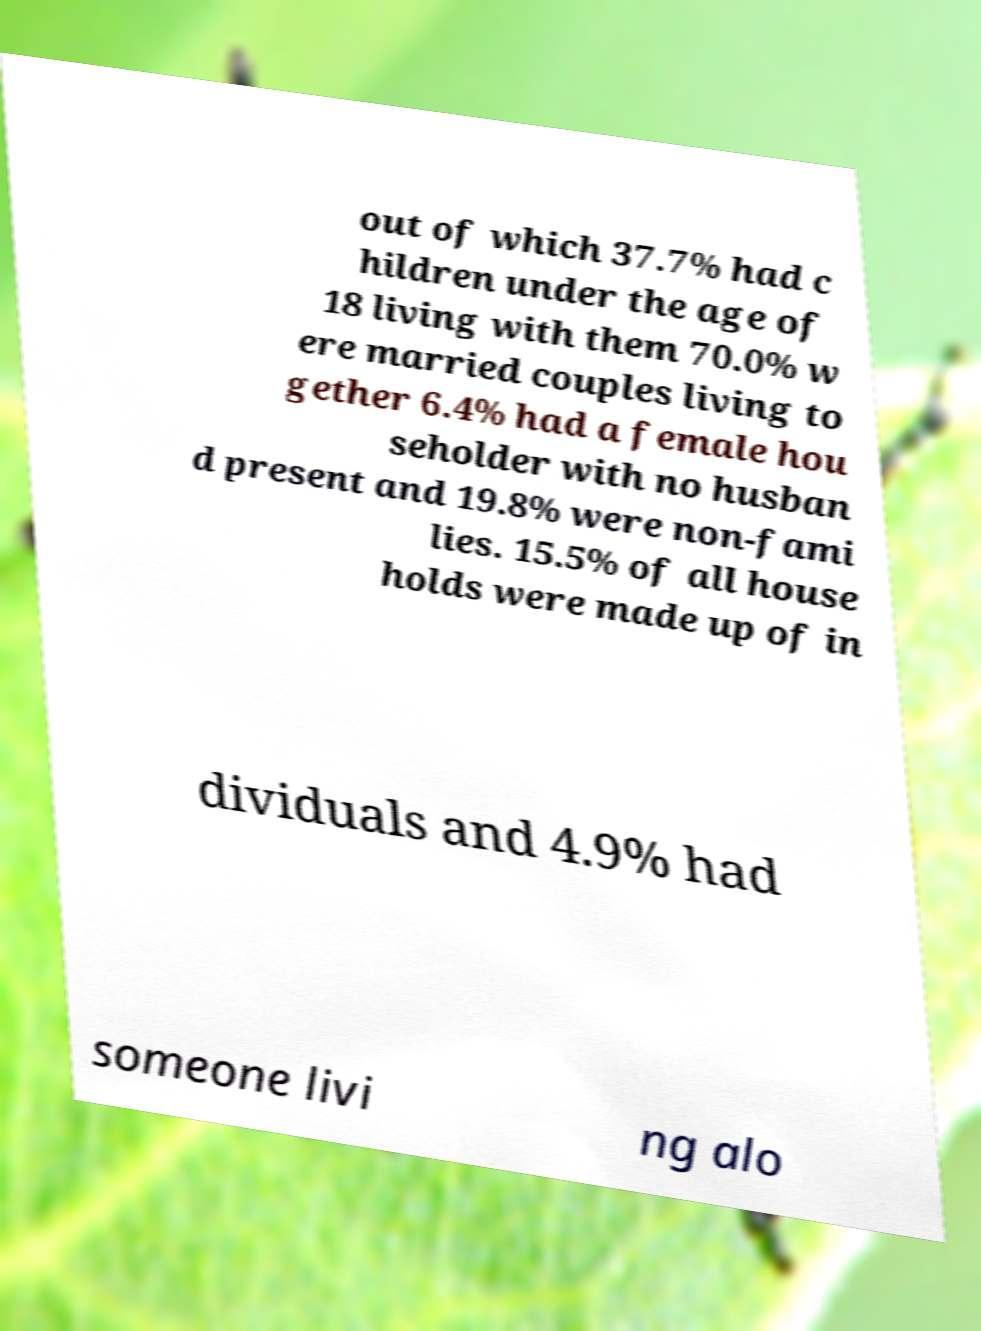Could you assist in decoding the text presented in this image and type it out clearly? out of which 37.7% had c hildren under the age of 18 living with them 70.0% w ere married couples living to gether 6.4% had a female hou seholder with no husban d present and 19.8% were non-fami lies. 15.5% of all house holds were made up of in dividuals and 4.9% had someone livi ng alo 